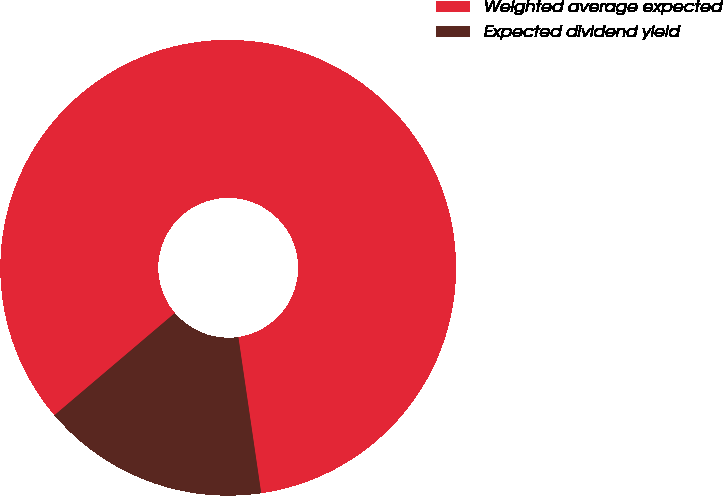Convert chart to OTSL. <chart><loc_0><loc_0><loc_500><loc_500><pie_chart><fcel>Weighted average expected<fcel>Expected dividend yield<nl><fcel>83.89%<fcel>16.11%<nl></chart> 